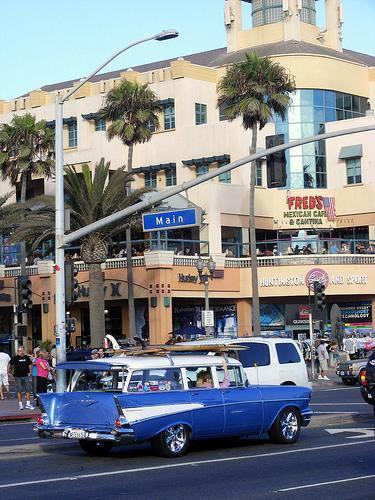How many cars are at least partially visible?
Give a very brief answer. 4. 